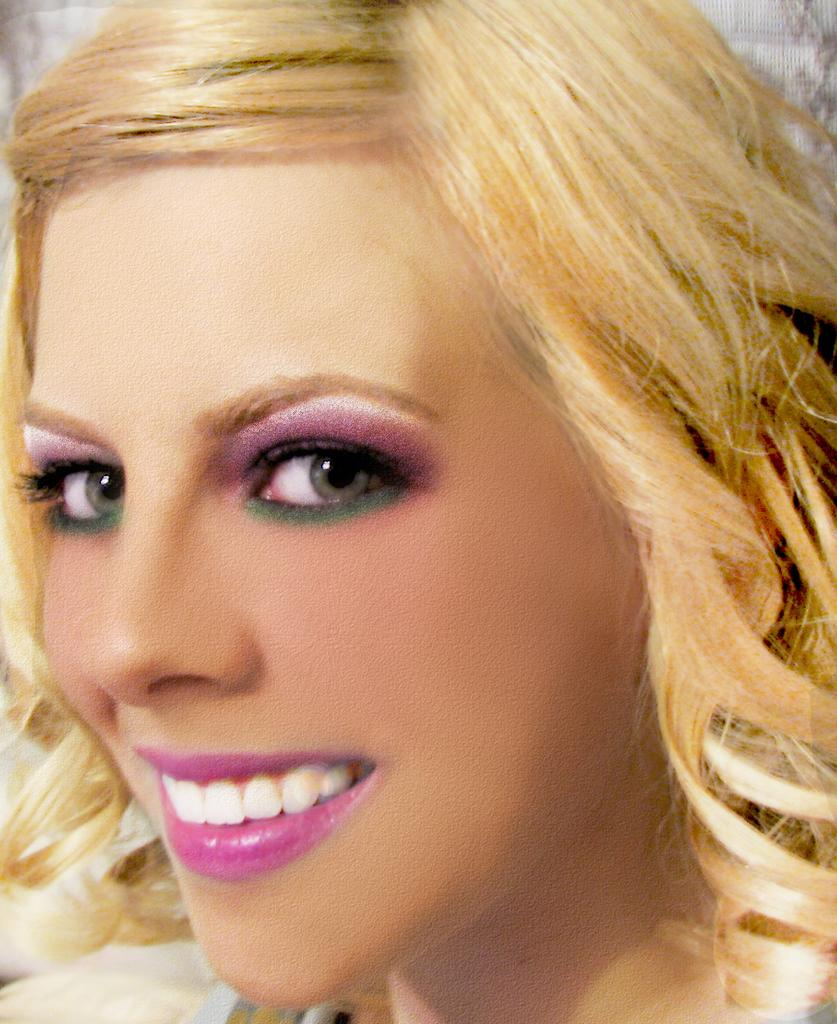What is the main subject of the image? There is a lady's face in the image. What is the name of the river flowing behind the lady in the image? There is no river present in the image; it only features a lady's face. 